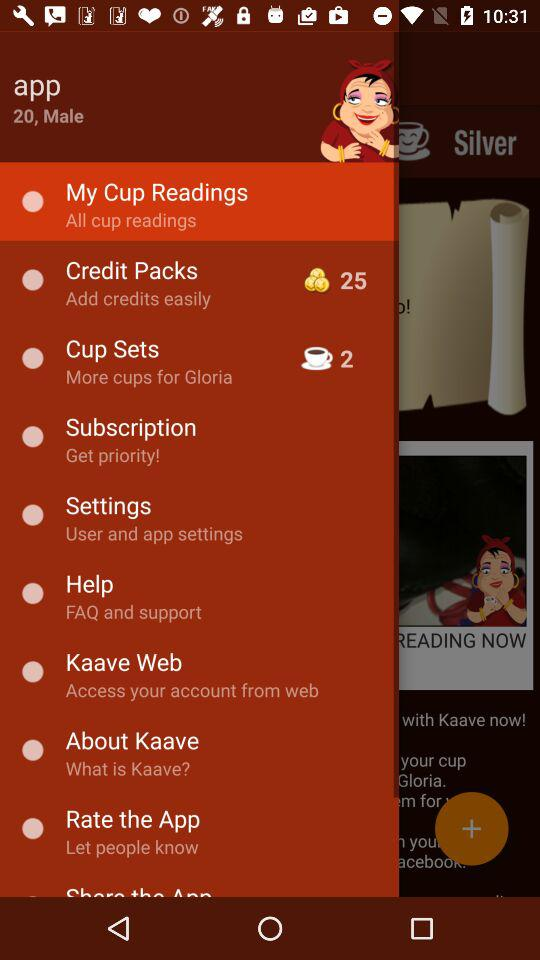What is the gender of the App? The gender is male. 